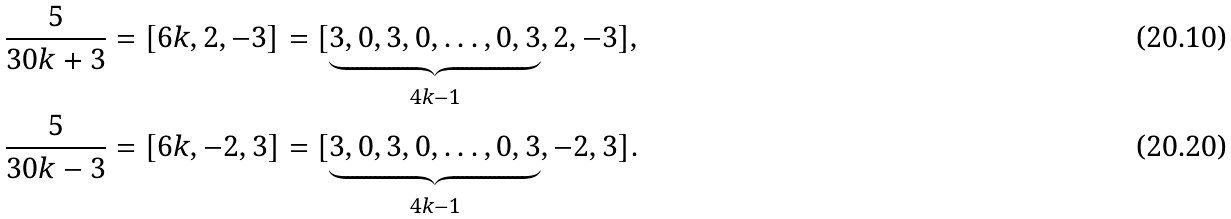<formula> <loc_0><loc_0><loc_500><loc_500>\frac { 5 } { 3 0 k + 3 } & = [ 6 k , 2 , - 3 ] = [ \underbrace { 3 , 0 , 3 , 0 , \dots , 0 , 3 } _ { 4 k - 1 } , 2 , - 3 ] , \\ \frac { 5 } { 3 0 k - 3 } & = [ 6 k , - 2 , 3 ] = [ \underbrace { 3 , 0 , 3 , 0 , \dots , 0 , 3 } _ { 4 k - 1 } , - 2 , 3 ] .</formula> 